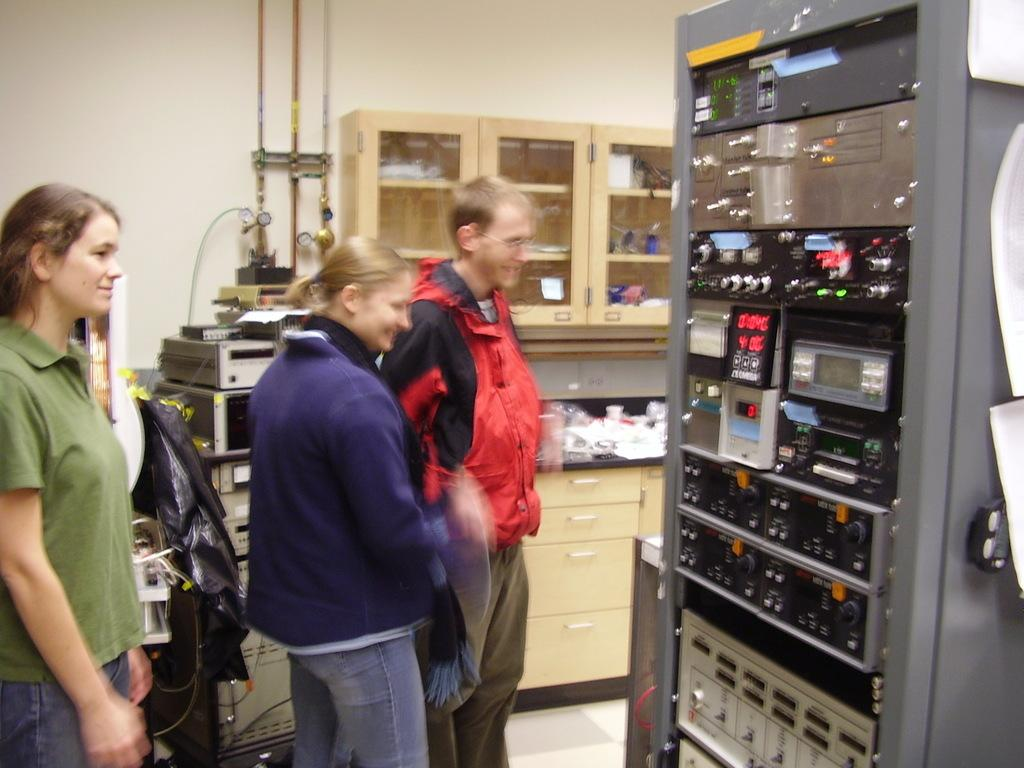Who are the people in the image? The facts provided do not give any information about the people's names or identities. What is the object on the right side of the image? The facts provided do not specify what the object is. What is inside the cupboard? The facts provided mention that there are objects inside the cupboard, but they do not specify what those objects are. What are the additional objects beside the cupboard? The facts provided do not specify what the additional objects are. What is the name of the beetle crawling on the question in the image? There is no beetle or question present in the image. 